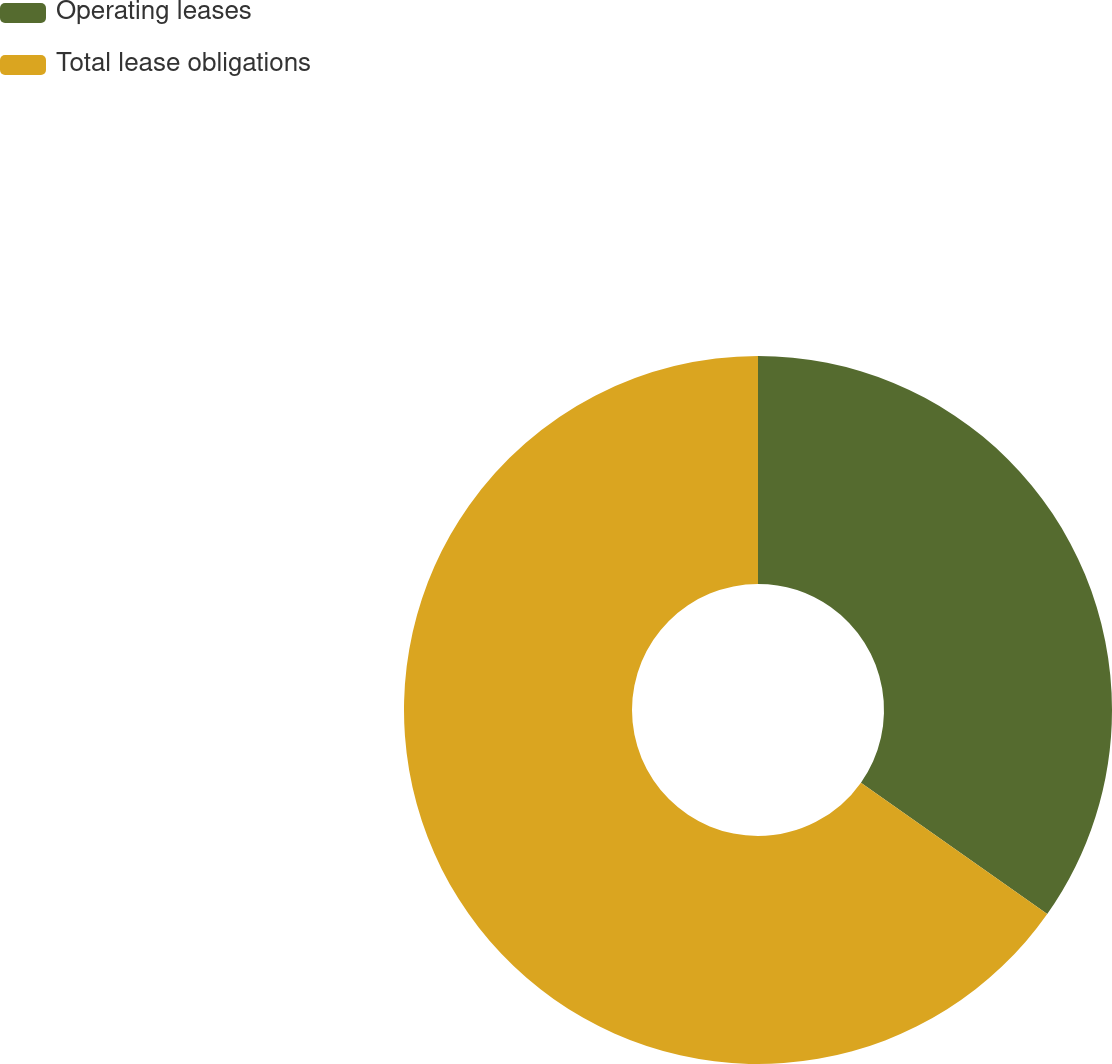Convert chart. <chart><loc_0><loc_0><loc_500><loc_500><pie_chart><fcel>Operating leases<fcel>Total lease obligations<nl><fcel>34.78%<fcel>65.22%<nl></chart> 